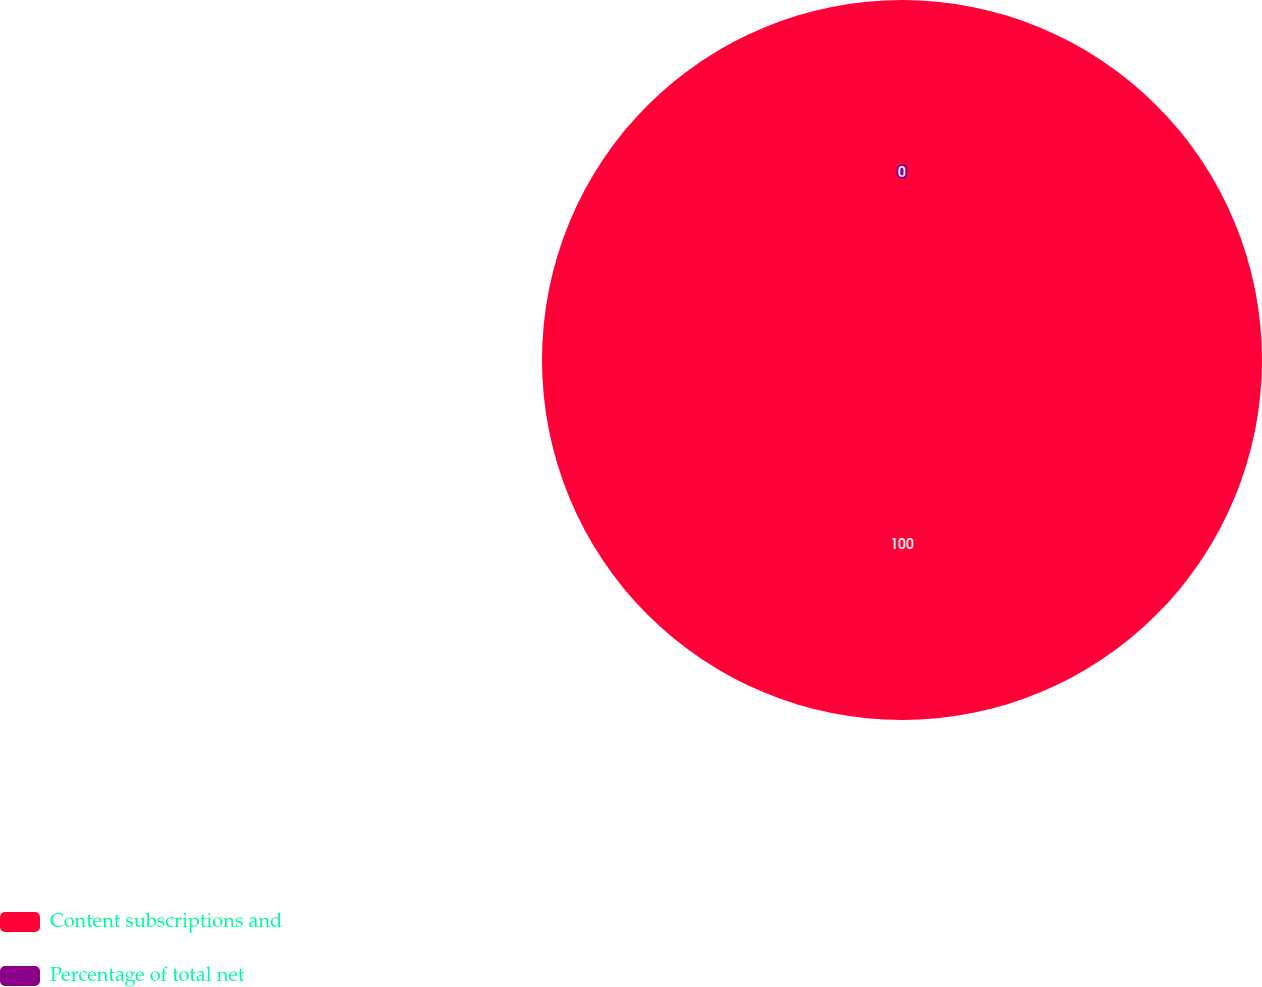Convert chart to OTSL. <chart><loc_0><loc_0><loc_500><loc_500><pie_chart><fcel>Content subscriptions and<fcel>Percentage of total net<nl><fcel>100.0%<fcel>0.0%<nl></chart> 